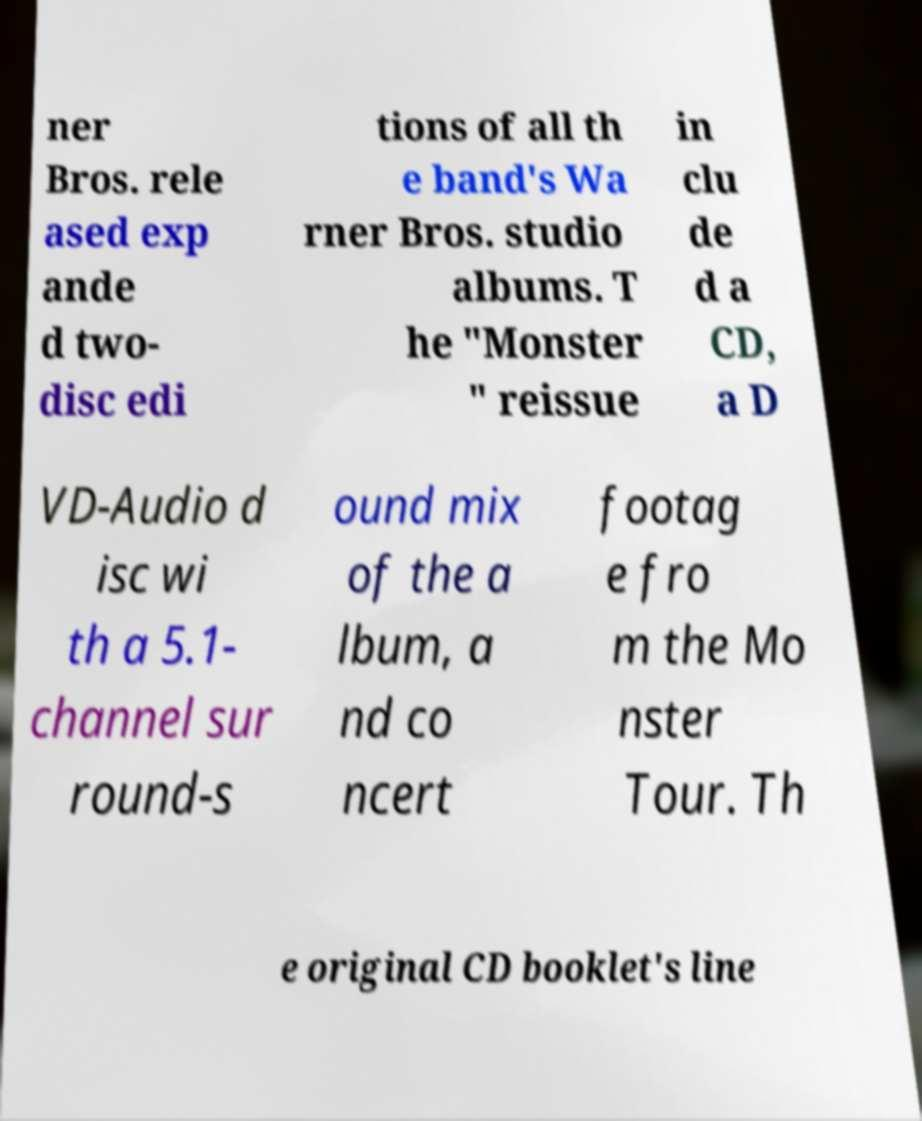Please identify and transcribe the text found in this image. ner Bros. rele ased exp ande d two- disc edi tions of all th e band's Wa rner Bros. studio albums. T he "Monster " reissue in clu de d a CD, a D VD-Audio d isc wi th a 5.1- channel sur round-s ound mix of the a lbum, a nd co ncert footag e fro m the Mo nster Tour. Th e original CD booklet's line 